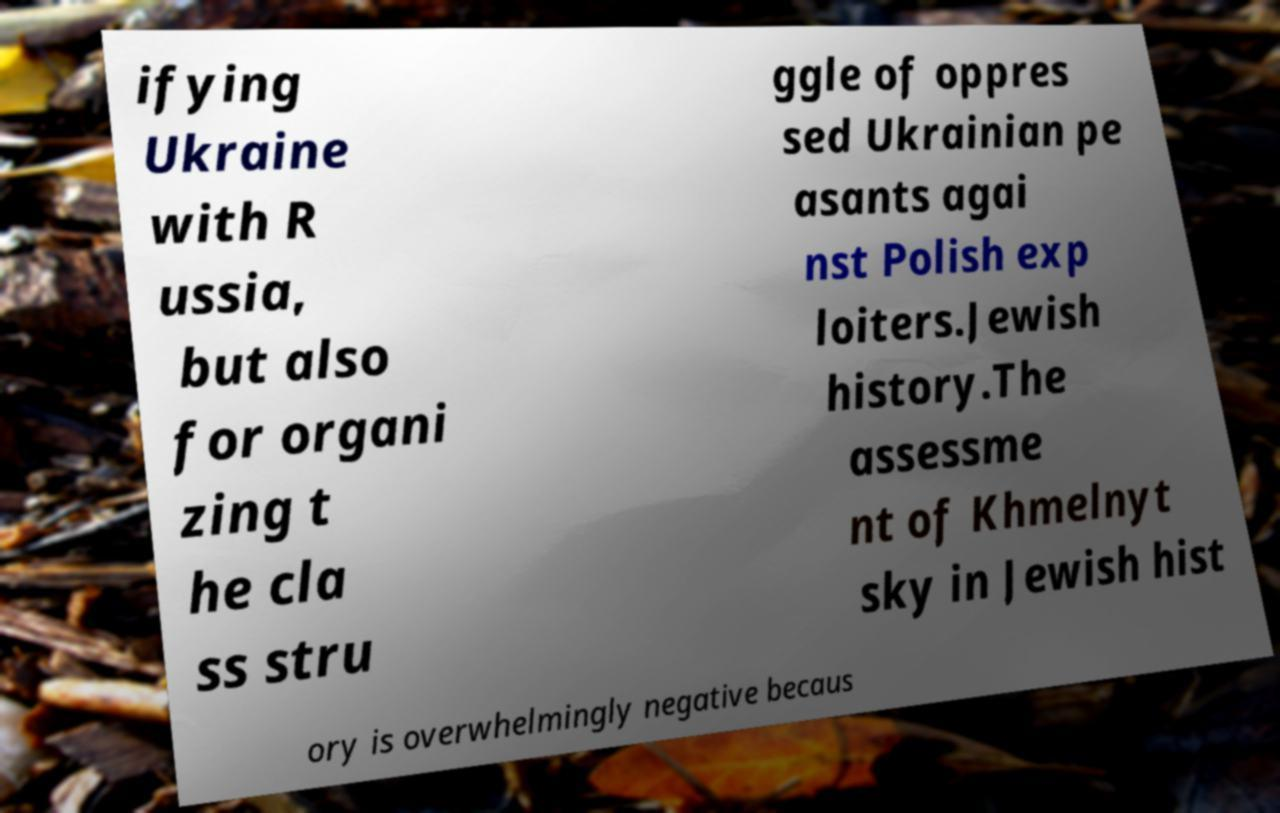Please identify and transcribe the text found in this image. ifying Ukraine with R ussia, but also for organi zing t he cla ss stru ggle of oppres sed Ukrainian pe asants agai nst Polish exp loiters.Jewish history.The assessme nt of Khmelnyt sky in Jewish hist ory is overwhelmingly negative becaus 